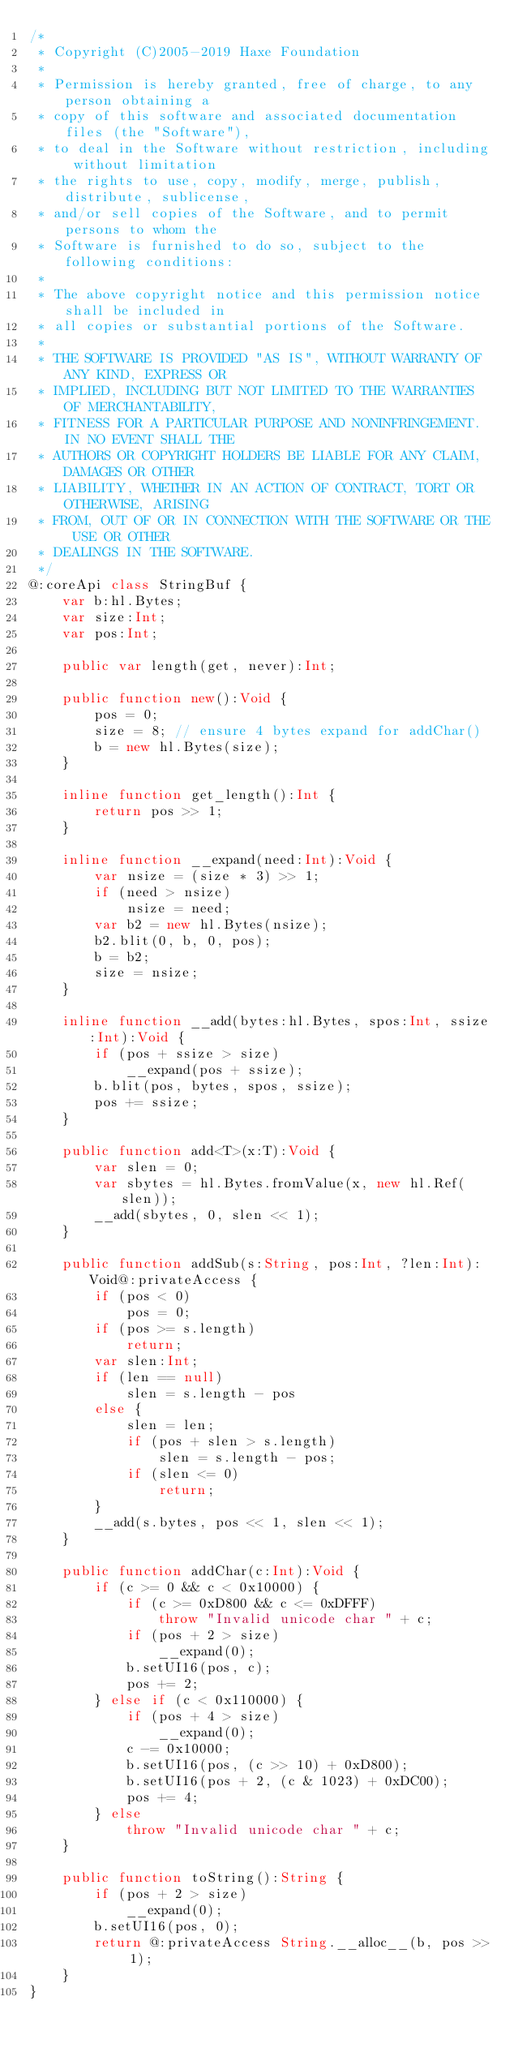<code> <loc_0><loc_0><loc_500><loc_500><_Haxe_>/*
 * Copyright (C)2005-2019 Haxe Foundation
 *
 * Permission is hereby granted, free of charge, to any person obtaining a
 * copy of this software and associated documentation files (the "Software"),
 * to deal in the Software without restriction, including without limitation
 * the rights to use, copy, modify, merge, publish, distribute, sublicense,
 * and/or sell copies of the Software, and to permit persons to whom the
 * Software is furnished to do so, subject to the following conditions:
 *
 * The above copyright notice and this permission notice shall be included in
 * all copies or substantial portions of the Software.
 *
 * THE SOFTWARE IS PROVIDED "AS IS", WITHOUT WARRANTY OF ANY KIND, EXPRESS OR
 * IMPLIED, INCLUDING BUT NOT LIMITED TO THE WARRANTIES OF MERCHANTABILITY,
 * FITNESS FOR A PARTICULAR PURPOSE AND NONINFRINGEMENT. IN NO EVENT SHALL THE
 * AUTHORS OR COPYRIGHT HOLDERS BE LIABLE FOR ANY CLAIM, DAMAGES OR OTHER
 * LIABILITY, WHETHER IN AN ACTION OF CONTRACT, TORT OR OTHERWISE, ARISING
 * FROM, OUT OF OR IN CONNECTION WITH THE SOFTWARE OR THE USE OR OTHER
 * DEALINGS IN THE SOFTWARE.
 */
@:coreApi class StringBuf {
	var b:hl.Bytes;
	var size:Int;
	var pos:Int;

	public var length(get, never):Int;

	public function new():Void {
		pos = 0;
		size = 8; // ensure 4 bytes expand for addChar()
		b = new hl.Bytes(size);
	}

	inline function get_length():Int {
		return pos >> 1;
	}

	inline function __expand(need:Int):Void {
		var nsize = (size * 3) >> 1;
		if (need > nsize)
			nsize = need;
		var b2 = new hl.Bytes(nsize);
		b2.blit(0, b, 0, pos);
		b = b2;
		size = nsize;
	}

	inline function __add(bytes:hl.Bytes, spos:Int, ssize:Int):Void {
		if (pos + ssize > size)
			__expand(pos + ssize);
		b.blit(pos, bytes, spos, ssize);
		pos += ssize;
	}

	public function add<T>(x:T):Void {
		var slen = 0;
		var sbytes = hl.Bytes.fromValue(x, new hl.Ref(slen));
		__add(sbytes, 0, slen << 1);
	}

	public function addSub(s:String, pos:Int, ?len:Int):Void@:privateAccess {
		if (pos < 0)
			pos = 0;
		if (pos >= s.length)
			return;
		var slen:Int;
		if (len == null)
			slen = s.length - pos
		else {
			slen = len;
			if (pos + slen > s.length)
				slen = s.length - pos;
			if (slen <= 0)
				return;
		}
		__add(s.bytes, pos << 1, slen << 1);
	}

	public function addChar(c:Int):Void {
		if (c >= 0 && c < 0x10000) {
			if (c >= 0xD800 && c <= 0xDFFF)
				throw "Invalid unicode char " + c;
			if (pos + 2 > size)
				__expand(0);
			b.setUI16(pos, c);
			pos += 2;
		} else if (c < 0x110000) {
			if (pos + 4 > size)
				__expand(0);
			c -= 0x10000;
			b.setUI16(pos, (c >> 10) + 0xD800);
			b.setUI16(pos + 2, (c & 1023) + 0xDC00);
			pos += 4;
		} else
			throw "Invalid unicode char " + c;
	}

	public function toString():String {
		if (pos + 2 > size)
			__expand(0);
		b.setUI16(pos, 0);
		return @:privateAccess String.__alloc__(b, pos >> 1);
	}
}
</code> 